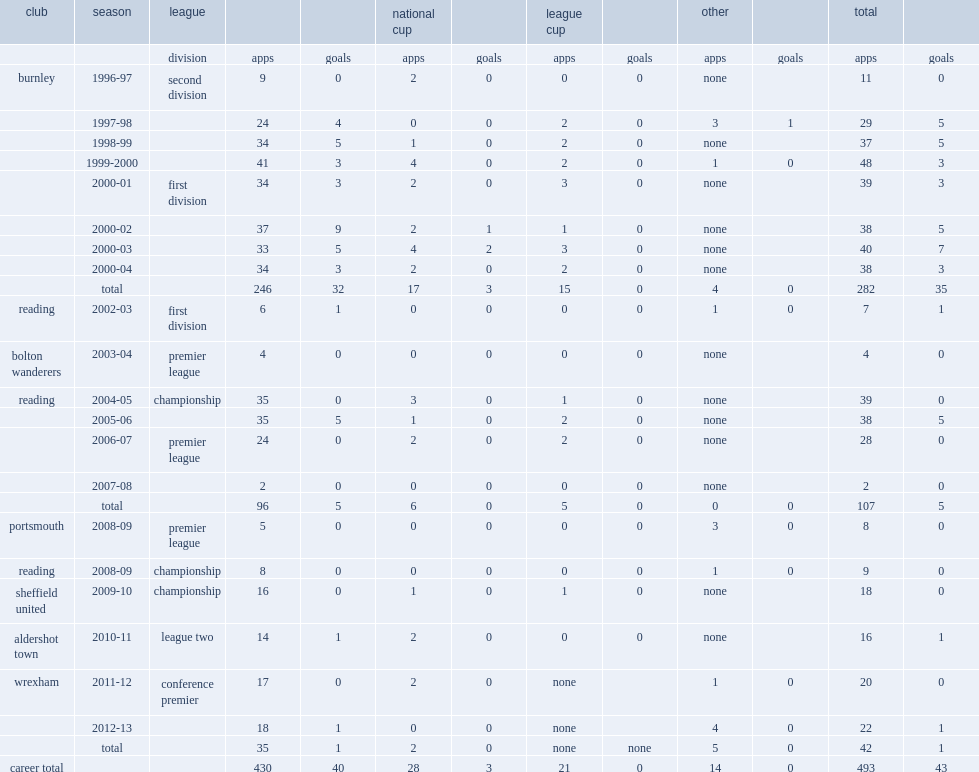How many goals did little score for reading in 2005-06? 5.0. 